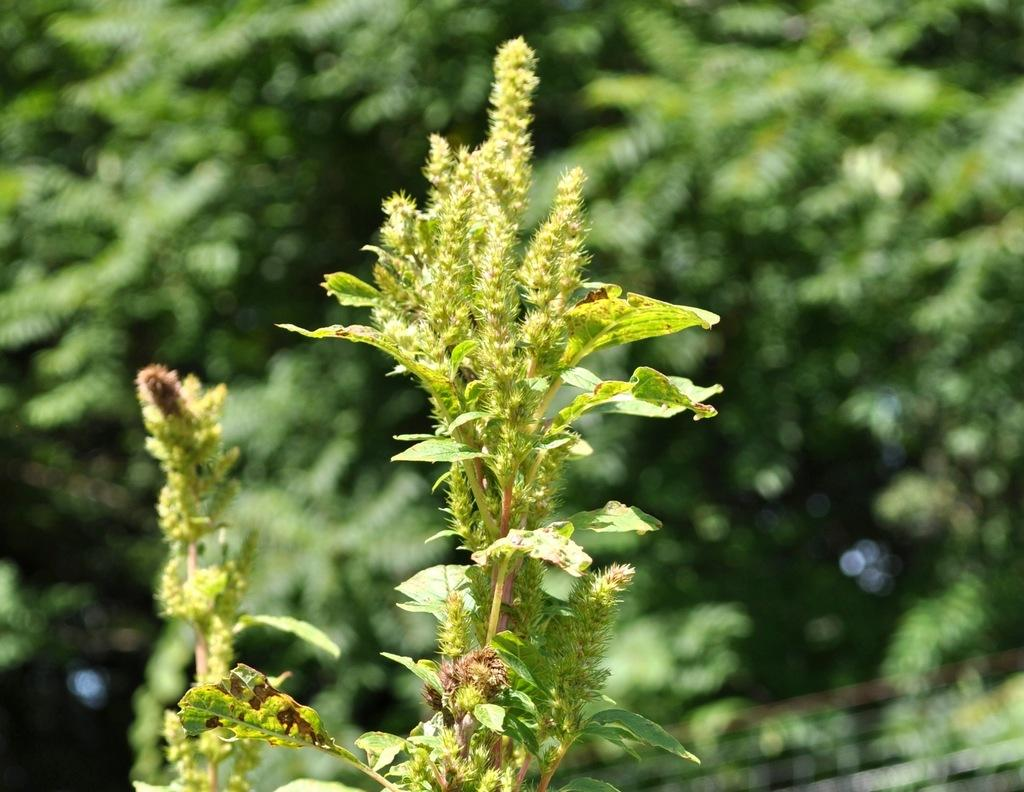What type of plant is located in the front of the image? There is a green plant in the front of the image. How would you describe the background of the image? The background of the image is blurred. What type of vegetation can be seen in the background of the image? There are green trees visible in the background of the image. Where is the nest of the bird located in the image? There is no nest or bird present in the image. Can you tell me how many islands are visible in the image? There are no islands visible in the image. 